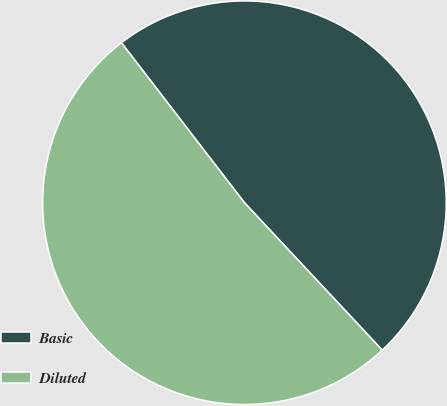Convert chart. <chart><loc_0><loc_0><loc_500><loc_500><pie_chart><fcel>Basic<fcel>Diluted<nl><fcel>48.47%<fcel>51.53%<nl></chart> 